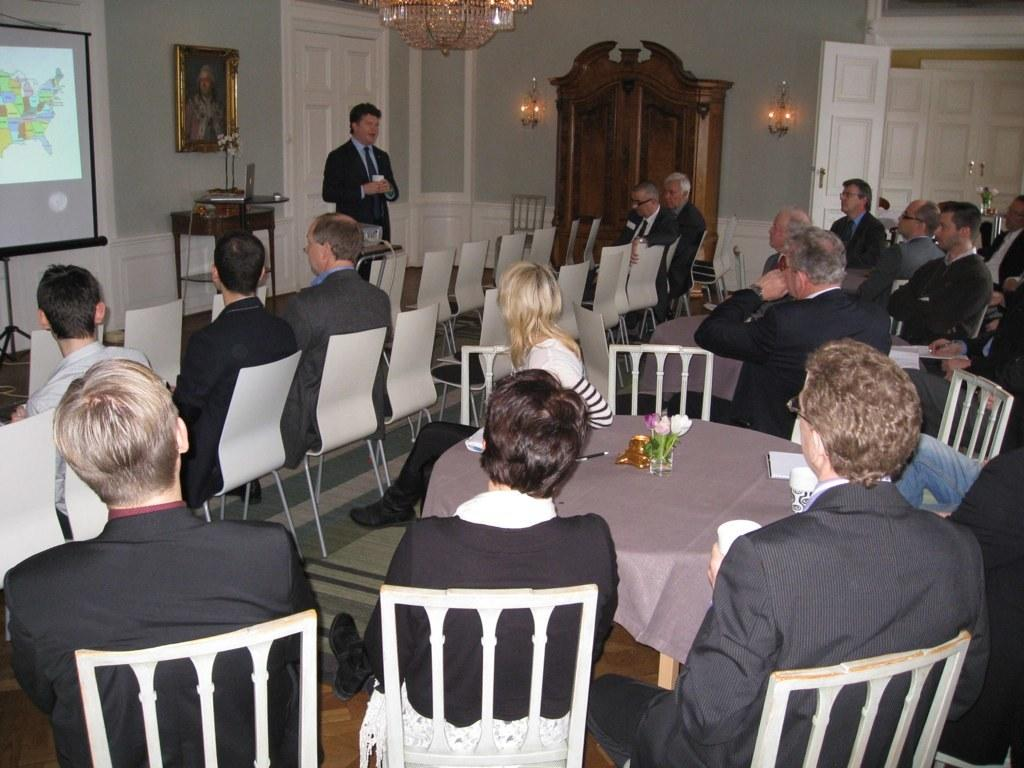What are the people in the image doing? The people in the image are sitting on chairs. Are there any other people in the image besides those sitting on chairs? Yes, there is a person standing in the image. What type of plate is the grandmother holding in the image? There is no grandmother or plate present in the image. 